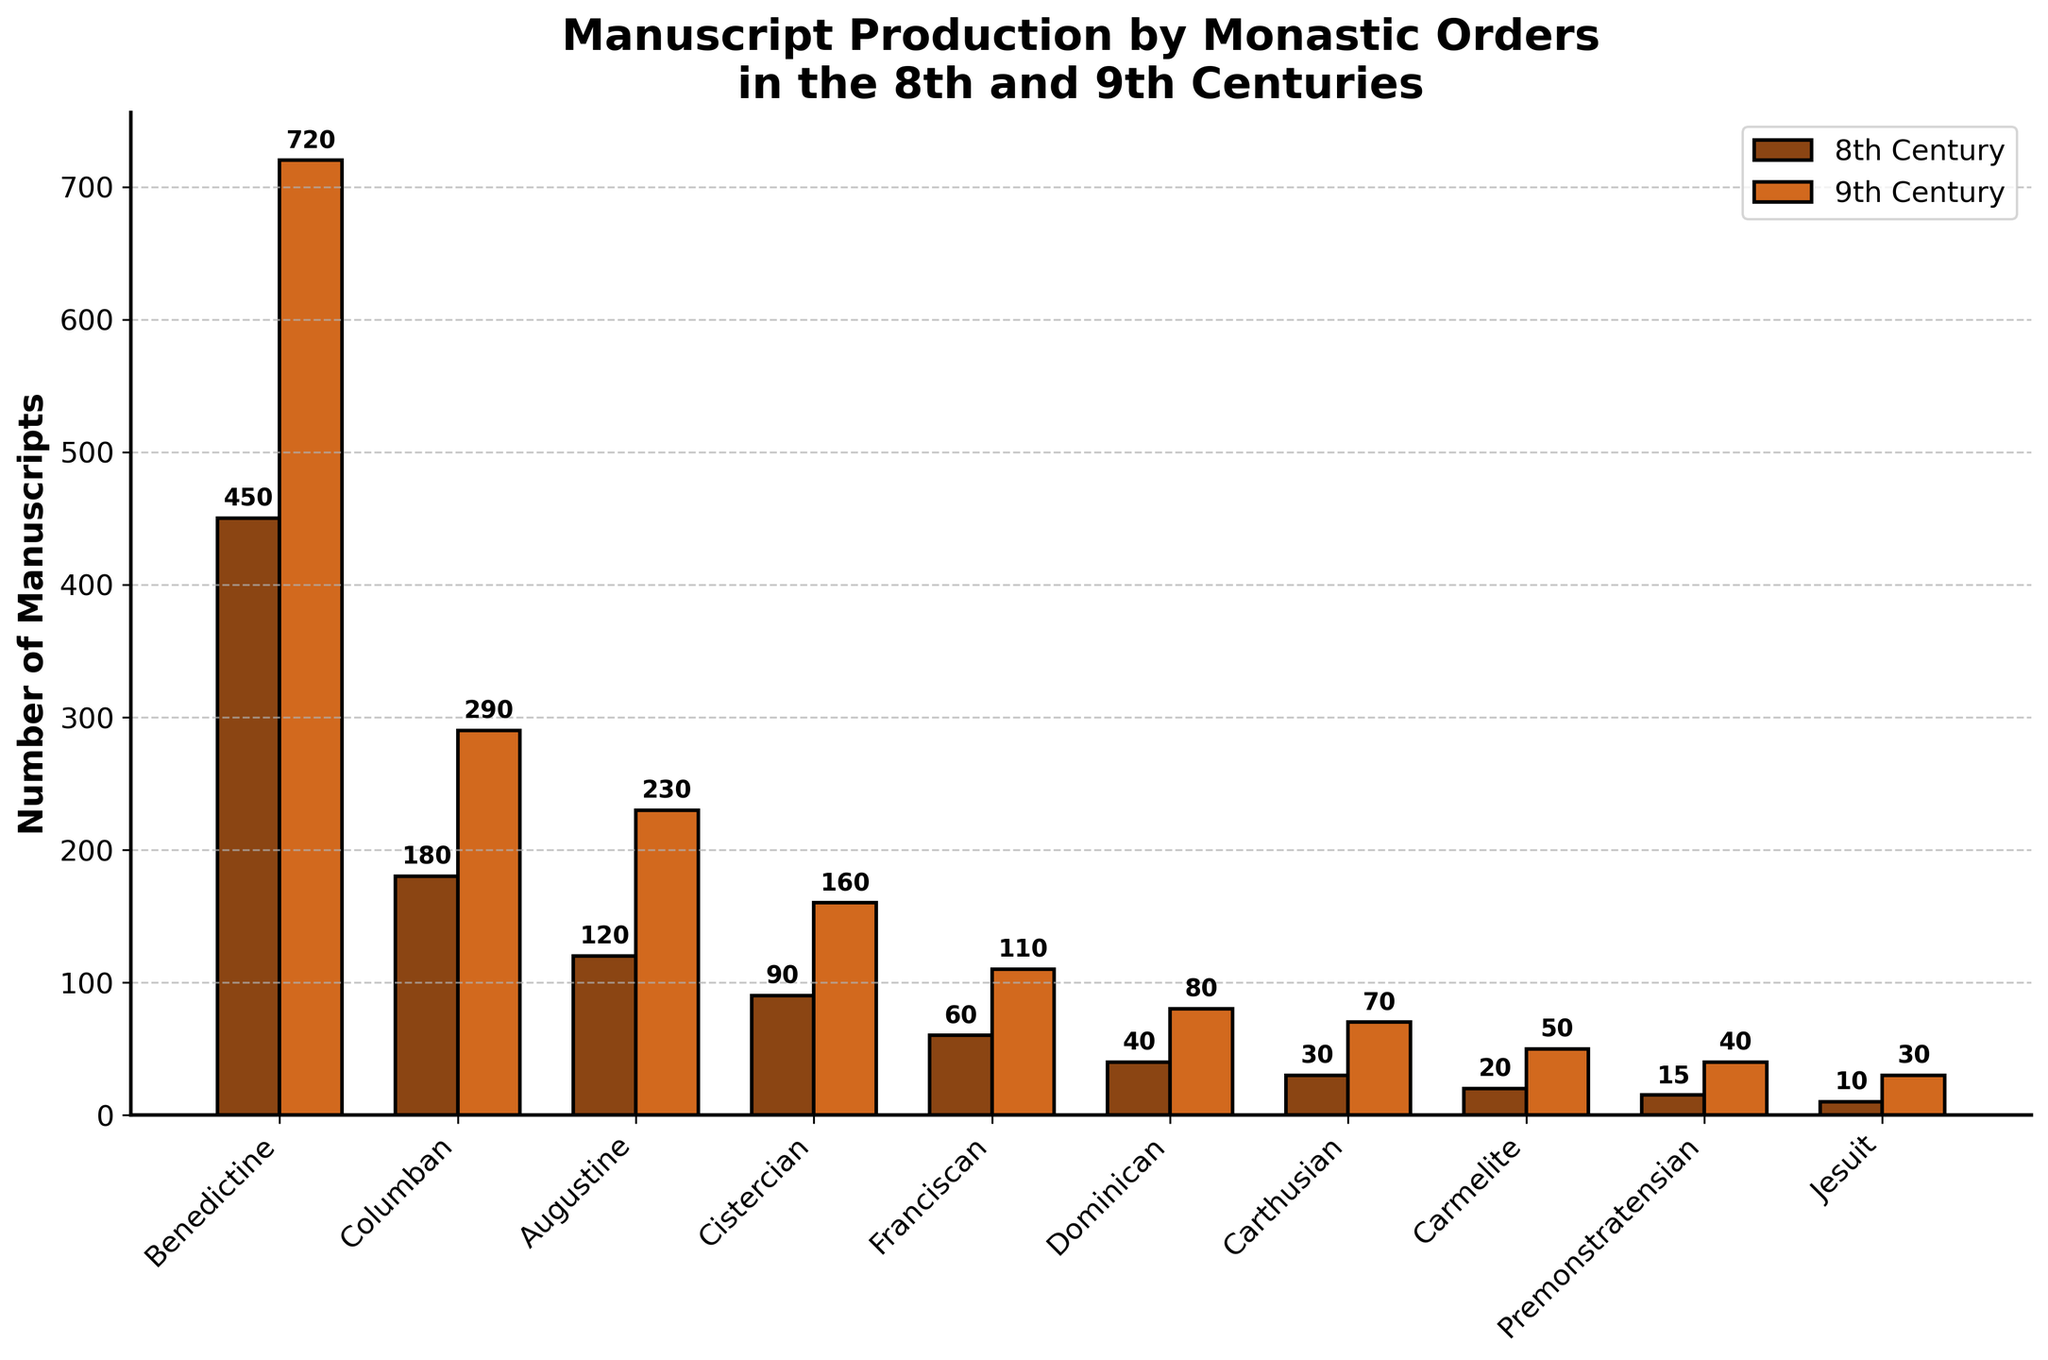Which order produced the most manuscripts in the 9th century? Observe the bar heights for the 9th century across all orders. The Benedictine order has the highest bar, which indicates the largest number of manuscripts.
Answer: Benedictine By how much did the manuscript production of the Columban order increase from the 8th to the 9th century? Subtract the number of manuscripts produced in the 8th century (180) from the number of manuscripts produced in the 9th century (290). 290 - 180 = 110
Answer: 110 Compare the production of manuscripts between the Augustine and Cistercian orders in the 8th century. Look at the bars representing the 8th century for the Augustine and Cistercian orders. The Augustine order has a taller bar compared to the Cistercian order (120 vs. 90).
Answer: Augustine > Cistercian Which century saw a higher production of manuscripts for the Carmelite order? Compare the height of the bars for the 8th and 9th centuries. The 9th-century bar is taller, indicating higher production.
Answer: 9th century What is the total number of manuscripts produced by the Benedictine order in both centuries combined? Add the number of manuscripts produced in the 8th century (450) to those in the 9th century (720). 450 + 720 = 1170
Answer: 1170 Of the orders listed, which produced the fewest manuscripts in the 8th century? Observe the height of the bars for the 8th century. The Jesuit order has the shortest bar, indicating the fewest manuscripts produced.
Answer: Jesuit How many more manuscripts did the Franciscan order produce in the 9th century compared to the 8th century? Subtract the number of manuscripts produced in the 8th century (60) from the number produced in the 9th century (110). 110 - 60 = 50
Answer: 50 Calculate the average number of manuscripts produced in the 8th century by the Dominican, Carthusian, and Carmelite orders. Sum the numbers of manuscripts produced by Dominican (40), Carthusian (30), and Carmelite (20) orders, and divide by 3. (40 + 30 + 20) / 3 = 90 / 3 = 30
Answer: 30 Which century had higher manuscript production for most of the orders? Compare the heights of bars for the 8th and 9th centuries across all orders. Most bars for the 9th century are taller than those for the 8th century.
Answer: 9th century How does the manuscript production of the Premonstratensian order in the 8th century compare to the Jesuit order in the 9th century? Compare the bar height of the Premonstratensian order in the 8th century (15) with the Jesuit order in the 9th century (30). The Jesuit order in the 9th century produced more.
Answer: Jesuit 9th century > Premonstratensian 8th century 